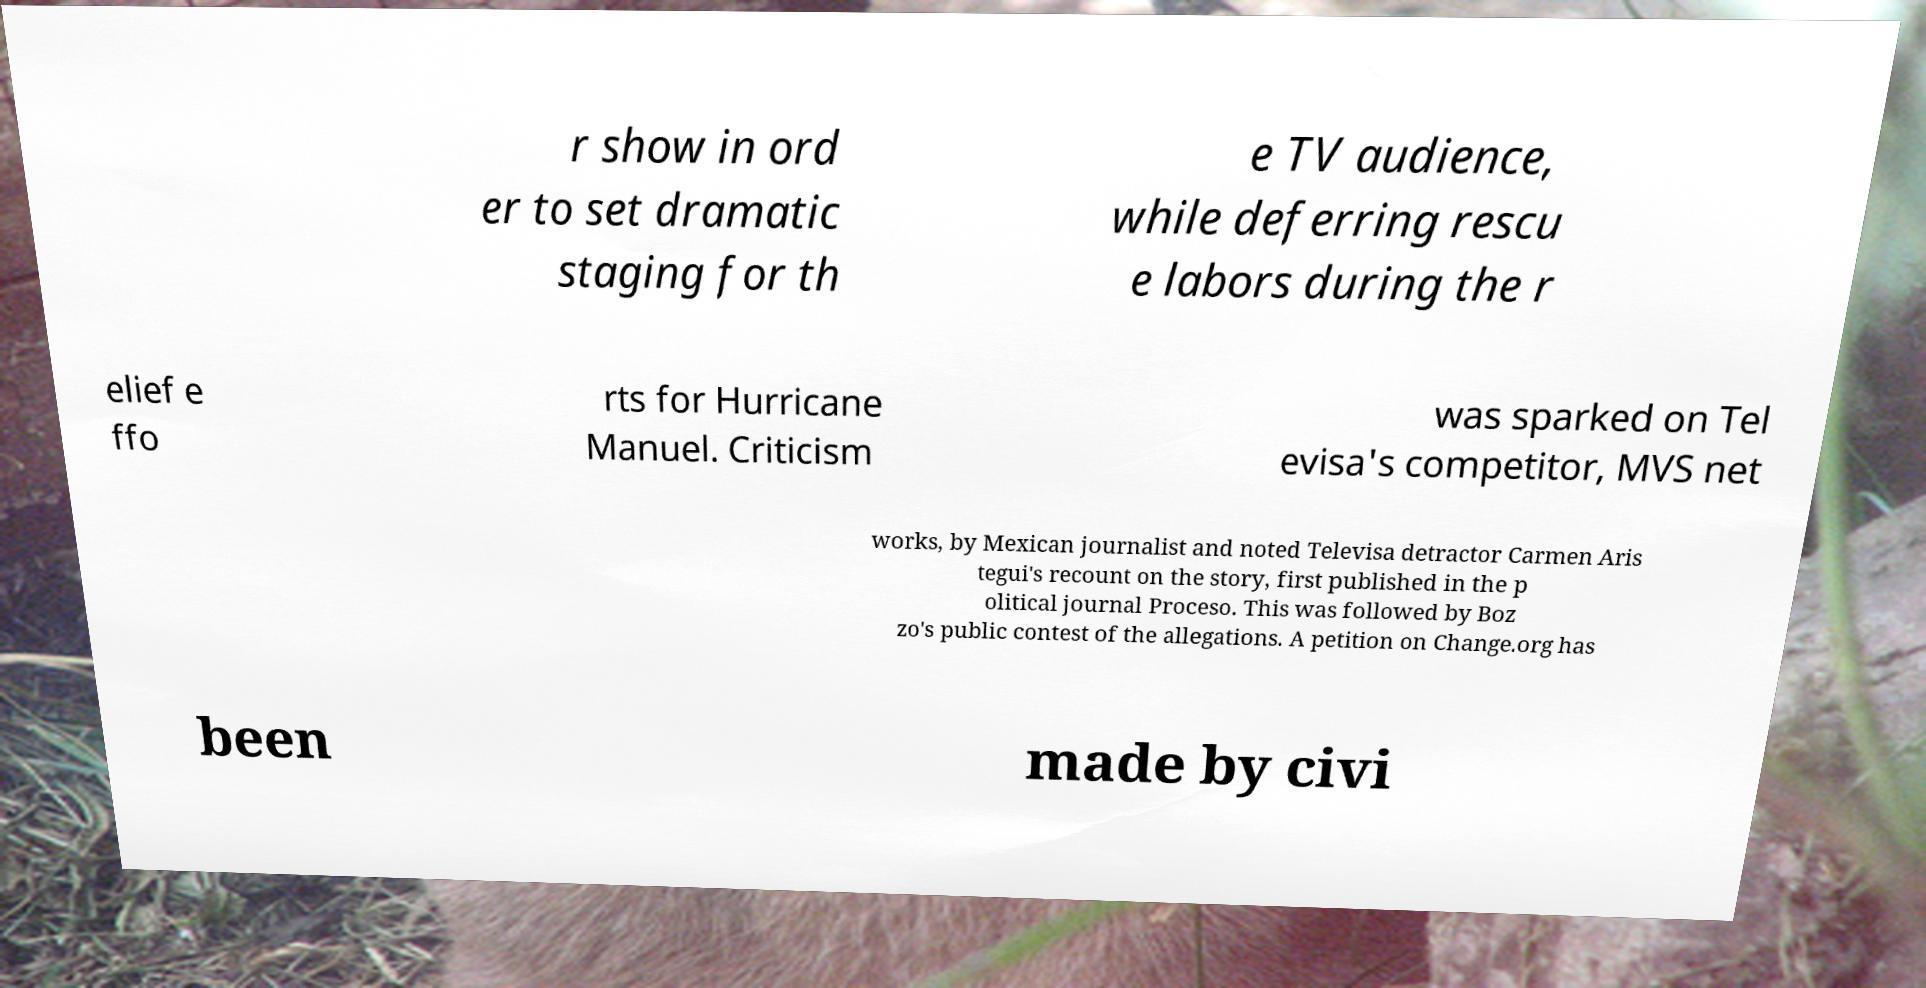Can you accurately transcribe the text from the provided image for me? r show in ord er to set dramatic staging for th e TV audience, while deferring rescu e labors during the r elief e ffo rts for Hurricane Manuel. Criticism was sparked on Tel evisa's competitor, MVS net works, by Mexican journalist and noted Televisa detractor Carmen Aris tegui's recount on the story, first published in the p olitical journal Proceso. This was followed by Boz zo's public contest of the allegations. A petition on Change.org has been made by civi 